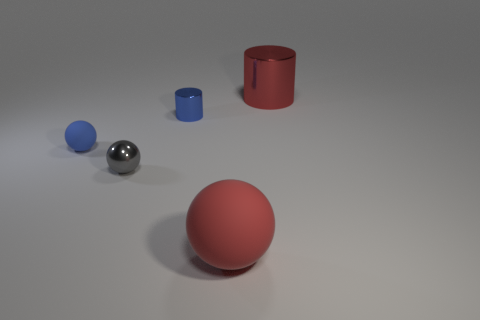Subtract all brown spheres. Subtract all blue cylinders. How many spheres are left? 3 Add 1 blue spheres. How many objects exist? 6 Subtract all balls. How many objects are left? 2 Subtract all small blue things. Subtract all matte balls. How many objects are left? 1 Add 1 big objects. How many big objects are left? 3 Add 3 small blue cylinders. How many small blue cylinders exist? 4 Subtract 0 cyan cylinders. How many objects are left? 5 